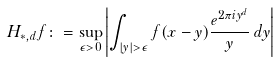<formula> <loc_0><loc_0><loc_500><loc_500>H _ { \ast , d } f & \colon = \sup _ { \epsilon > 0 } \left | \int _ { | y | > \epsilon } f ( x - y ) \frac { e ^ { 2 \pi i y ^ { d } } } y \, d y \right |</formula> 